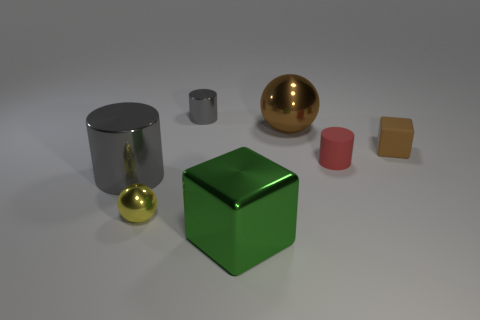How many other objects are there of the same color as the large shiny ball?
Your answer should be compact. 1. What number of objects are either blocks that are in front of the small yellow shiny thing or small gray metallic cylinders?
Your response must be concise. 2. Does the large shiny cube have the same color as the tiny cylinder on the left side of the large shiny ball?
Your answer should be very brief. No. Are there any other things that have the same size as the red matte cylinder?
Make the answer very short. Yes. What is the size of the brown thing to the right of the large thing that is behind the small brown matte object?
Give a very brief answer. Small. How many things are either small brown metal cylinders or metallic things left of the green shiny cube?
Offer a terse response. 3. There is a gray metal thing on the right side of the tiny yellow thing; is it the same shape as the large green object?
Offer a very short reply. No. There is a block behind the ball that is in front of the tiny cube; how many brown things are to the left of it?
Provide a succinct answer. 1. Is there anything else that is the same shape as the large gray object?
Your answer should be very brief. Yes. How many things are big purple rubber blocks or spheres?
Offer a very short reply. 2. 